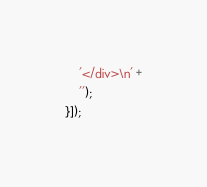Convert code to text. <code><loc_0><loc_0><loc_500><loc_500><_JavaScript_>    '</div>\n' +
    '');
}]);
</code> 